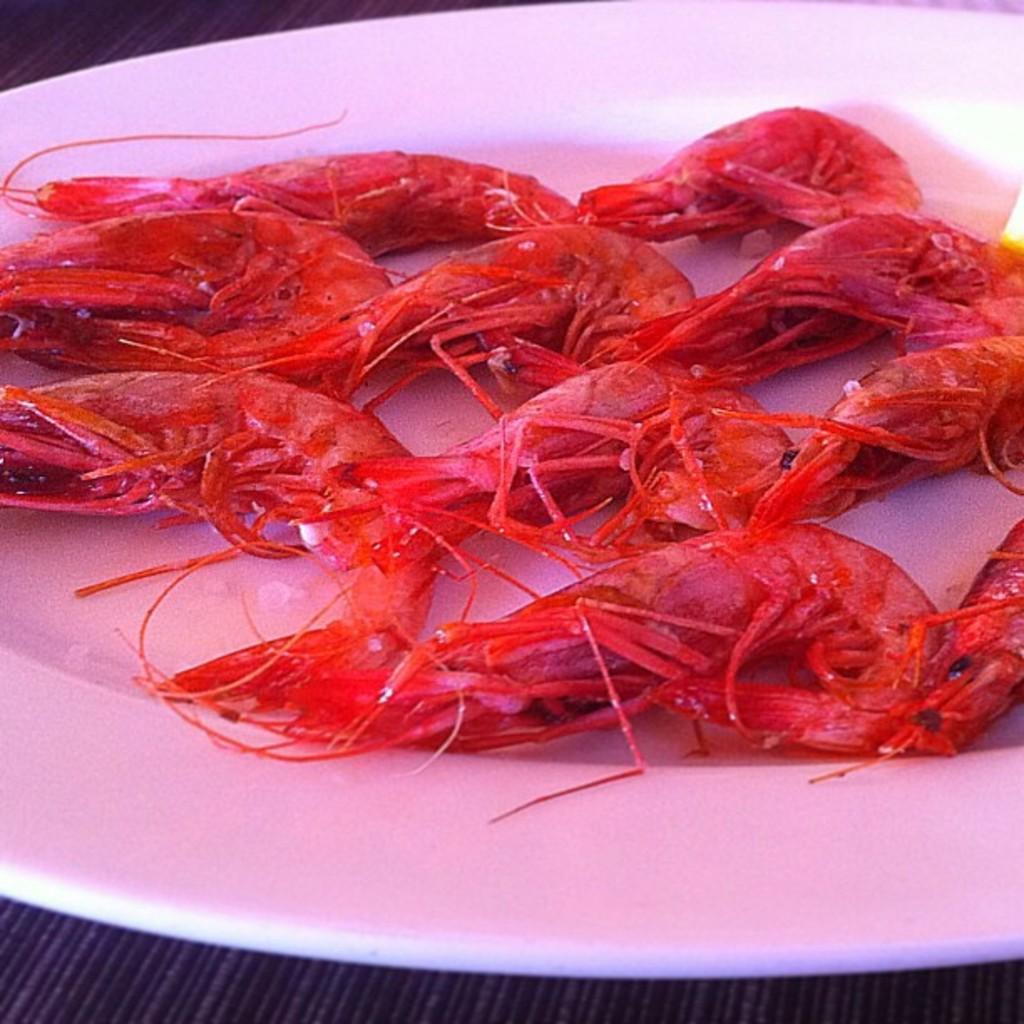Describe this image in one or two sentences. In the picture I can see seafood which is in white color plate which is on surface. 